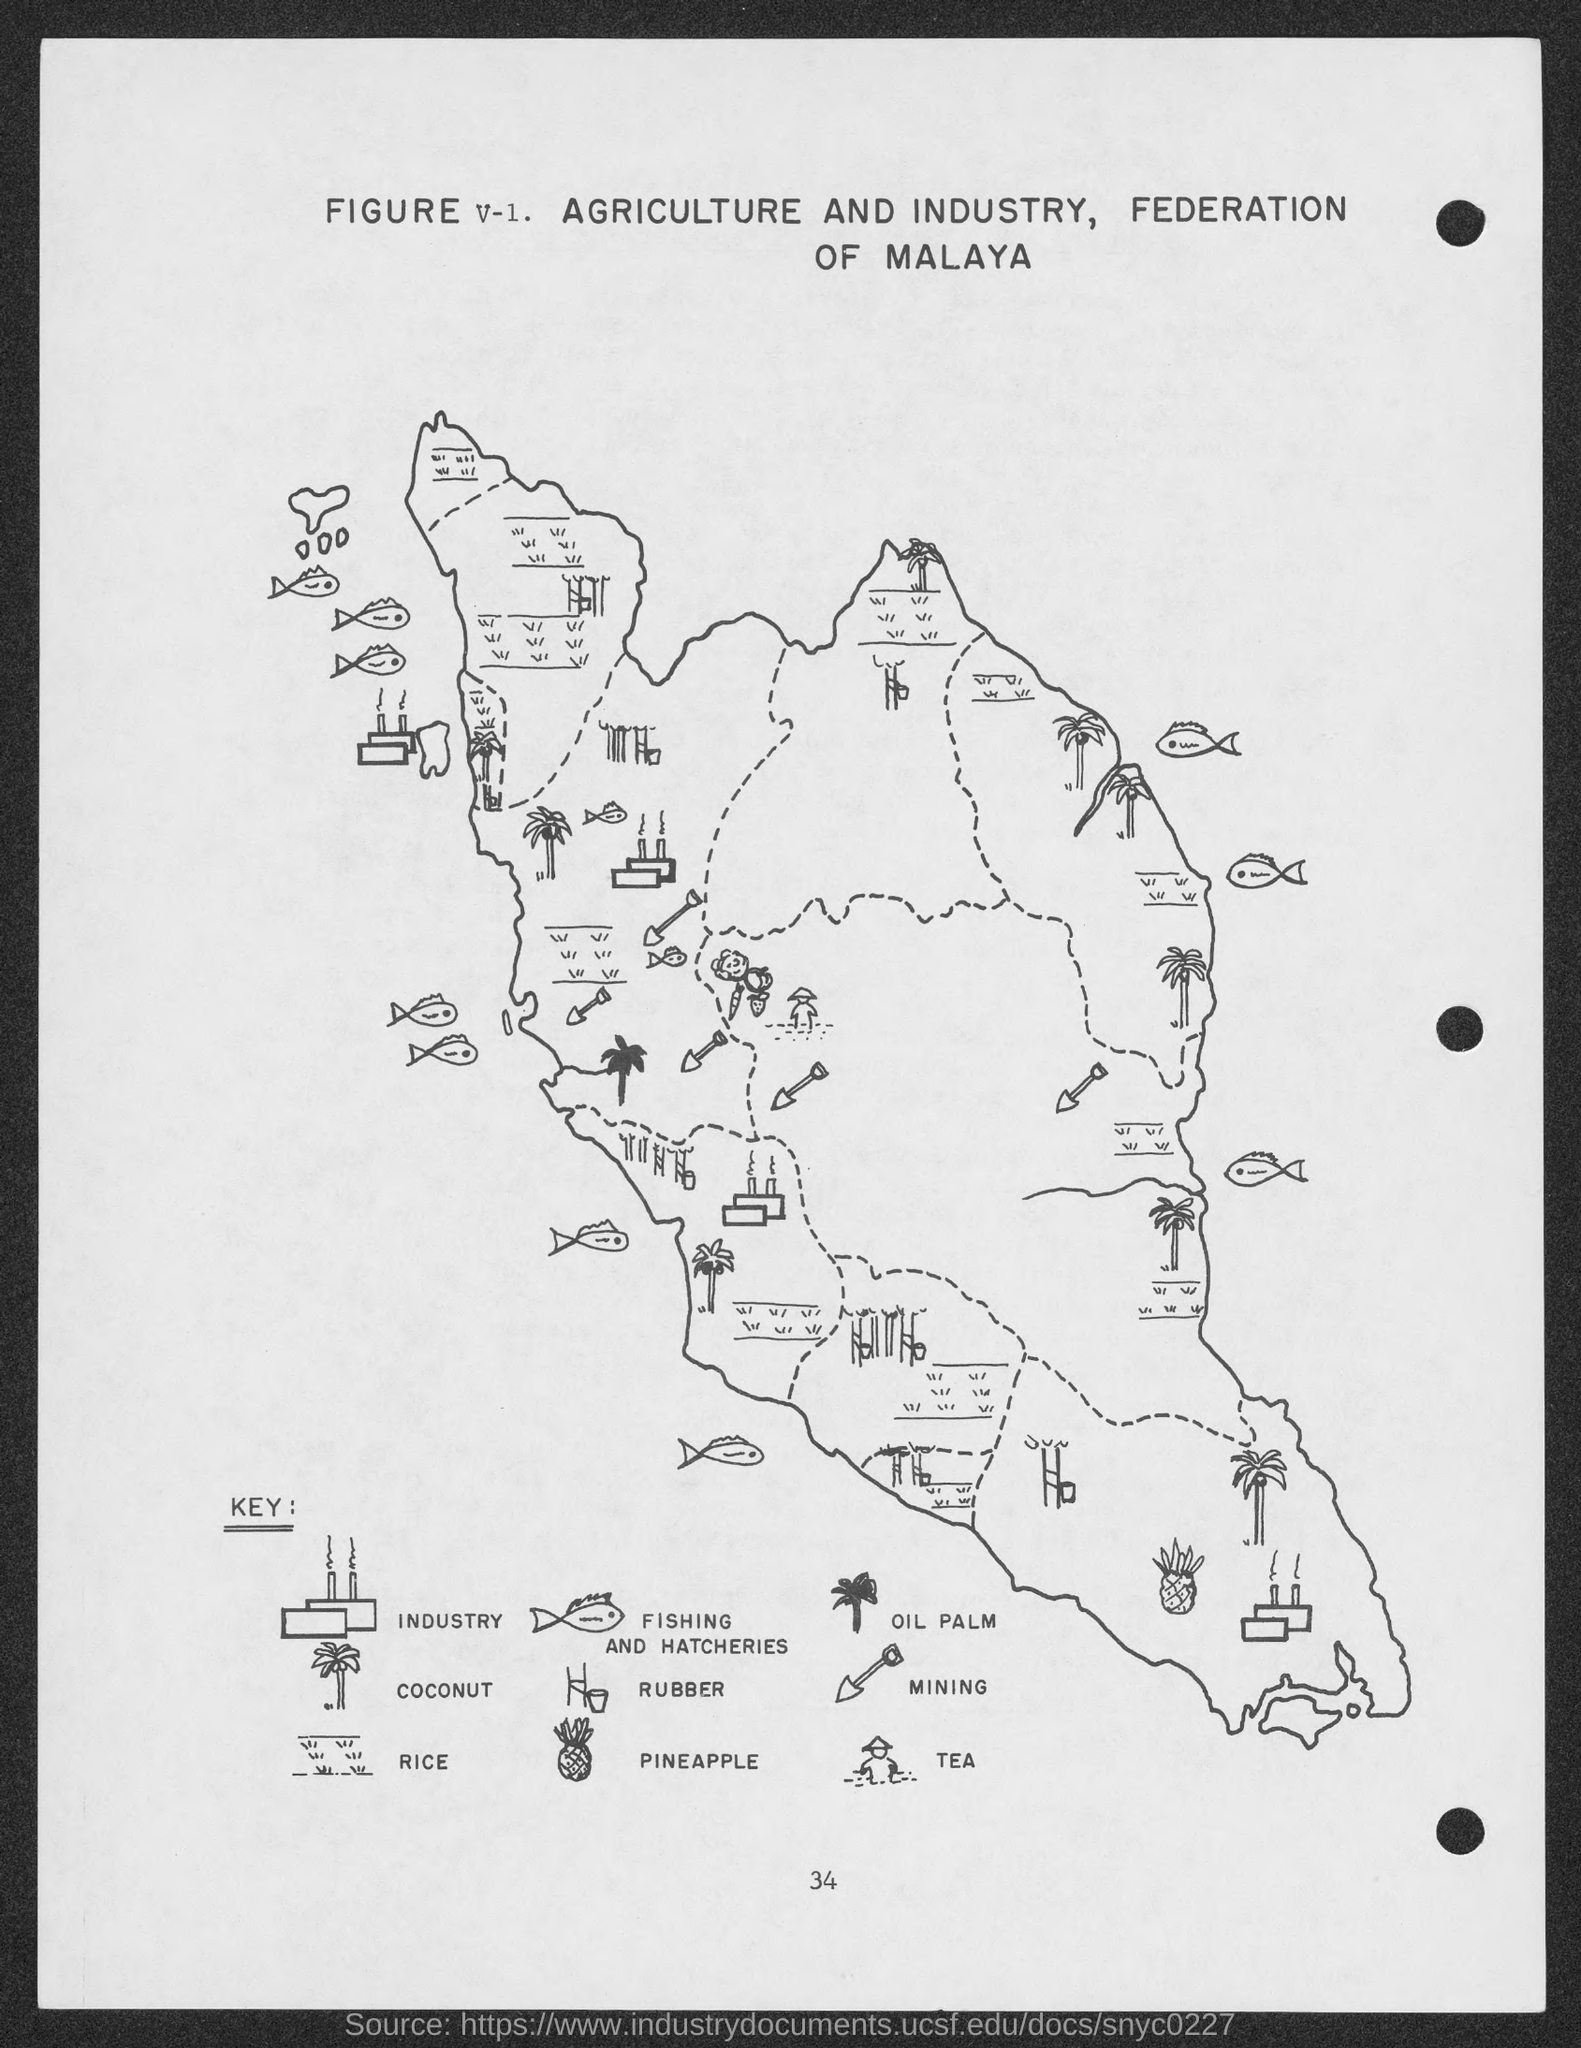What is the number at bottom of the page ?
Ensure brevity in your answer.  34. What is the figure no.?
Provide a succinct answer. V-1. 